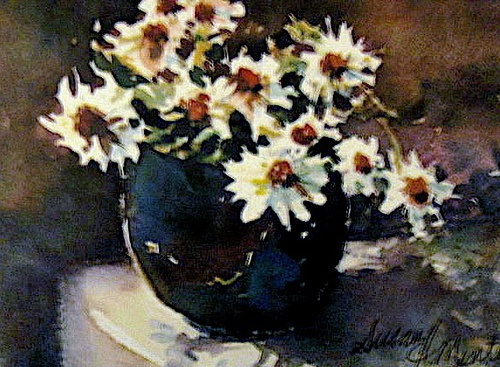Describe the objects in this image and their specific colors. I can see a vase in black, navy, blue, and gray tones in this image. 